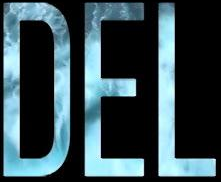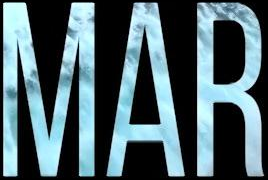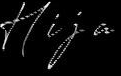Transcribe the words shown in these images in order, separated by a semicolon. DEL; MAR; Hija 